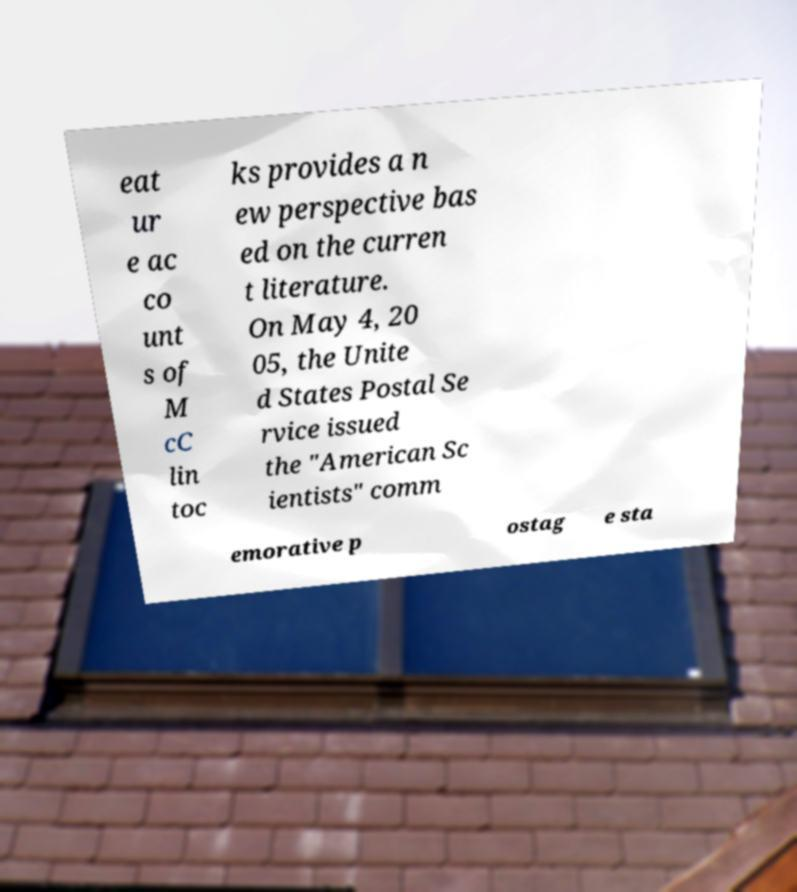Please read and relay the text visible in this image. What does it say? eat ur e ac co unt s of M cC lin toc ks provides a n ew perspective bas ed on the curren t literature. On May 4, 20 05, the Unite d States Postal Se rvice issued the "American Sc ientists" comm emorative p ostag e sta 